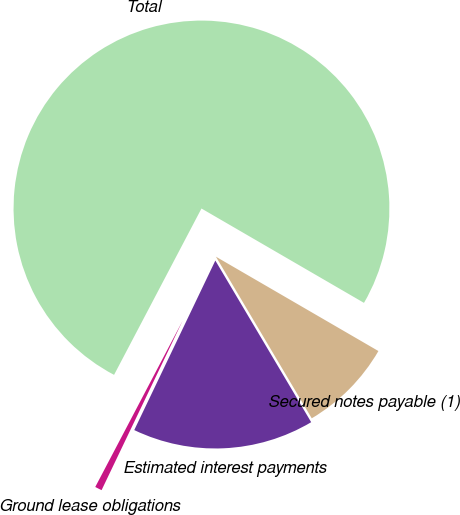<chart> <loc_0><loc_0><loc_500><loc_500><pie_chart><fcel>Secured notes payable (1)<fcel>Estimated interest payments<fcel>Ground lease obligations<fcel>Total<nl><fcel>8.11%<fcel>15.62%<fcel>0.6%<fcel>75.68%<nl></chart> 